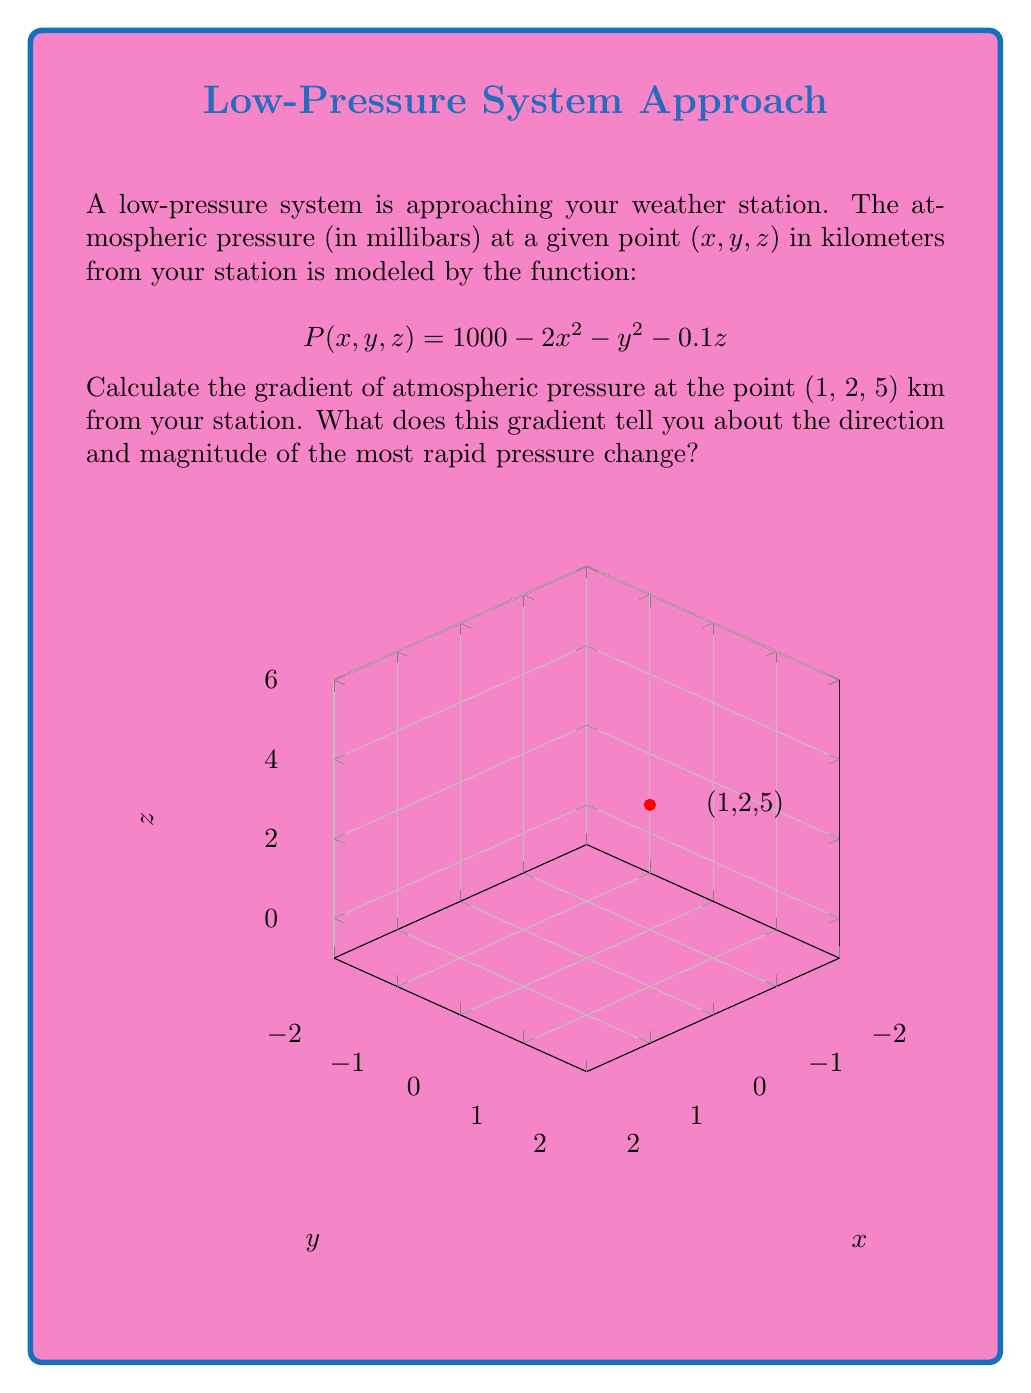Show me your answer to this math problem. To solve this problem, let's follow these steps:

1) The gradient of a scalar field $f(x, y, z)$ is defined as:

   $$\nabla f = \left(\frac{\partial f}{\partial x}, \frac{\partial f}{\partial y}, \frac{\partial f}{\partial z}\right)$$

2) For our pressure function $P(x, y, z) = 1000 - 2x^2 - y^2 - 0.1z$, we need to calculate the partial derivatives:

   $$\frac{\partial P}{\partial x} = -4x$$
   $$\frac{\partial P}{\partial y} = -2y$$
   $$\frac{\partial P}{\partial z} = -0.1$$

3) Now, we can form the gradient:

   $$\nabla P = (-4x, -2y, -0.1)$$

4) To find the gradient at the point (1, 2, 5), we substitute these values:

   $$\nabla P|_{(1,2,5)} = (-4(1), -2(2), -0.1) = (-4, -4, -0.1)$$

5) This gradient vector tells us:
   - Direction: The negative signs indicate that pressure decreases most rapidly in the direction of the vector (-4, -4, -0.1).
   - Magnitude: The magnitude of the gradient is $\sqrt{(-4)^2 + (-4)^2 + (-0.1)^2} \approx 5.66$ mb/km.

6) Interpretation: 
   - The pressure decreases most rapidly in a direction slightly southwest and very slightly downward from the given point.
   - The rate of this most rapid decrease is about 5.66 millibars per kilometer.
Answer: $$\nabla P|_{(1,2,5)} = (-4, -4, -0.1)$$ mb/km 